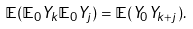<formula> <loc_0><loc_0><loc_500><loc_500>\mathbb { E } ( \mathbb { E } _ { 0 } Y _ { k } \mathbb { E } _ { 0 } Y _ { j } ) = \mathbb { E } ( Y _ { 0 } Y _ { k + j } ) .</formula> 